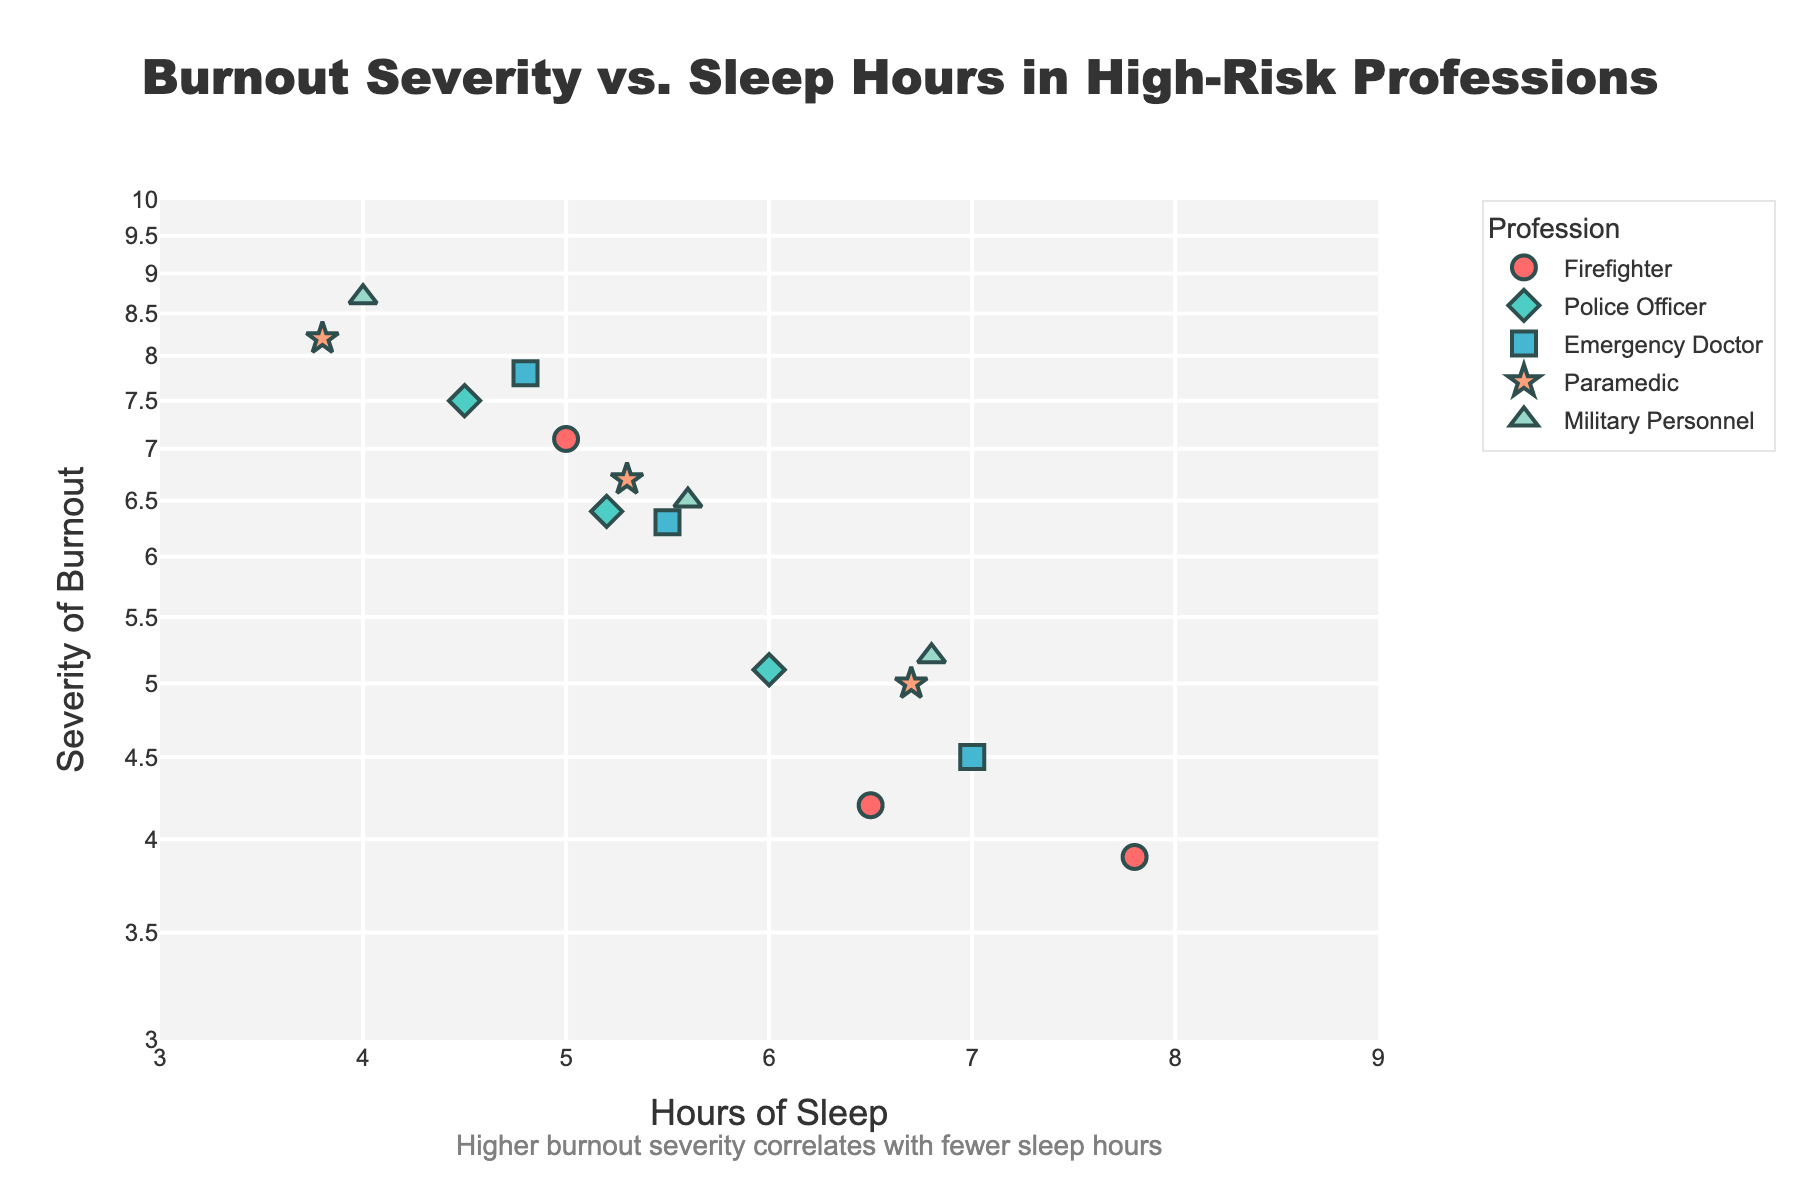What is the title of the scatter plot? The title of the figure is typically located at the top of the chart. For this scatter plot, it reads "Burnout Severity vs. Sleep Hours in High-Risk Professions".
Answer: Burnout Severity vs. Sleep Hours in High-Risk Professions Which profession has the highest severity of burnout symptoms? The highest severity of burnout symptoms corresponds to the data point farthest up the y-axis. This is for Military Personnel with a severity of 8.7.
Answer: Military Personnel What profession corresponds to the data point with 3.8 hours of sleep? We need to find the data point along the x-axis at 3.8 hours of sleep. The corresponding profession for this point is Paramedic with a burnout severity of 8.2.
Answer: Paramedic How many data points are there for Police Officers in the scatter plot? To determine this, count the number of markers that represent Police Officers. There are three markers for Police Officers indicating 3 data points.
Answer: 3 What is the approximate correlation between hours of sleep and severity of burnout symptoms? Observing the scatter plot, as the hours of sleep increase, the severity of burnout generally decreases. This suggests a negative correlation between hours of sleep and severity of burnout symptoms.
Answer: Negative correlation Which profession has the greatest variability in the severity of burnout symptoms? To determine variability, look for the profession with the widest spread along the y-axis. Firefighters have burnout severities ranging from around 3.9 to 7.1, indicating a high variability.
Answer: Firefighter For Emergency Doctors, what is the average severity of burnout symptoms? The burnout severities of Emergency Doctors are 7.8, 6.3, and 4.5. Summing these: 7.8 + 6.3 + 4.5 = 18.6. Dividing by 3, the average is 18.6 / 3 = 6.2.
Answer: 6.2 Which profession has a data point with the least hours of sleep? The least hours of sleep is 3.8, and this point corresponds to a Paramedic.
Answer: Paramedic 